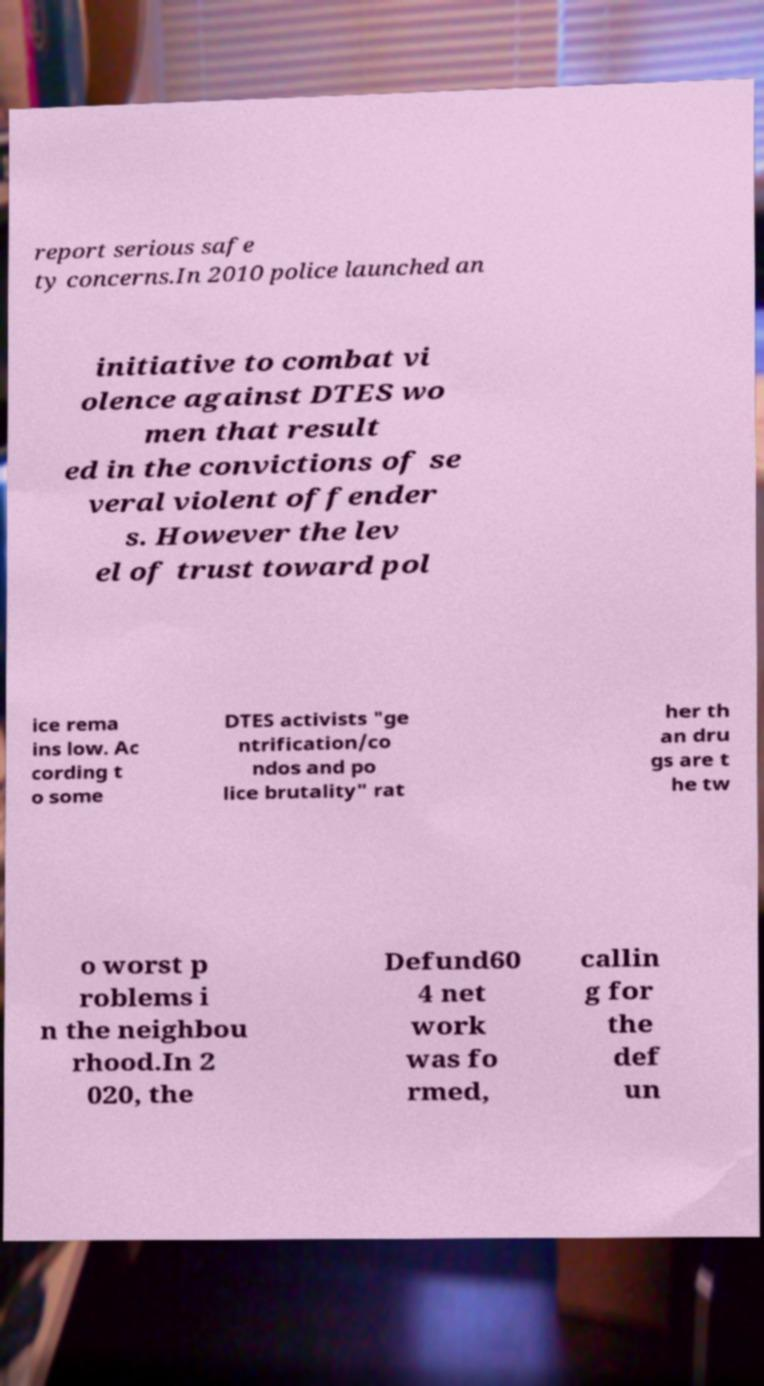Please identify and transcribe the text found in this image. report serious safe ty concerns.In 2010 police launched an initiative to combat vi olence against DTES wo men that result ed in the convictions of se veral violent offender s. However the lev el of trust toward pol ice rema ins low. Ac cording t o some DTES activists "ge ntrification/co ndos and po lice brutality" rat her th an dru gs are t he tw o worst p roblems i n the neighbou rhood.In 2 020, the Defund60 4 net work was fo rmed, callin g for the def un 